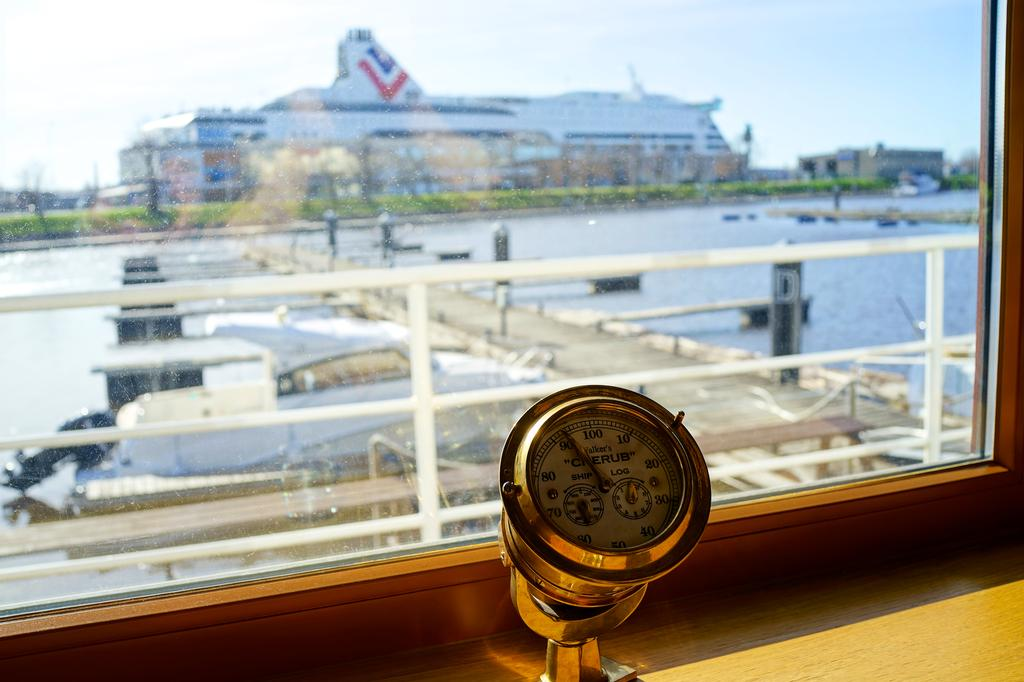<image>
Write a terse but informative summary of the picture. a gauge reading Ship Log in front of a window to a harbor 